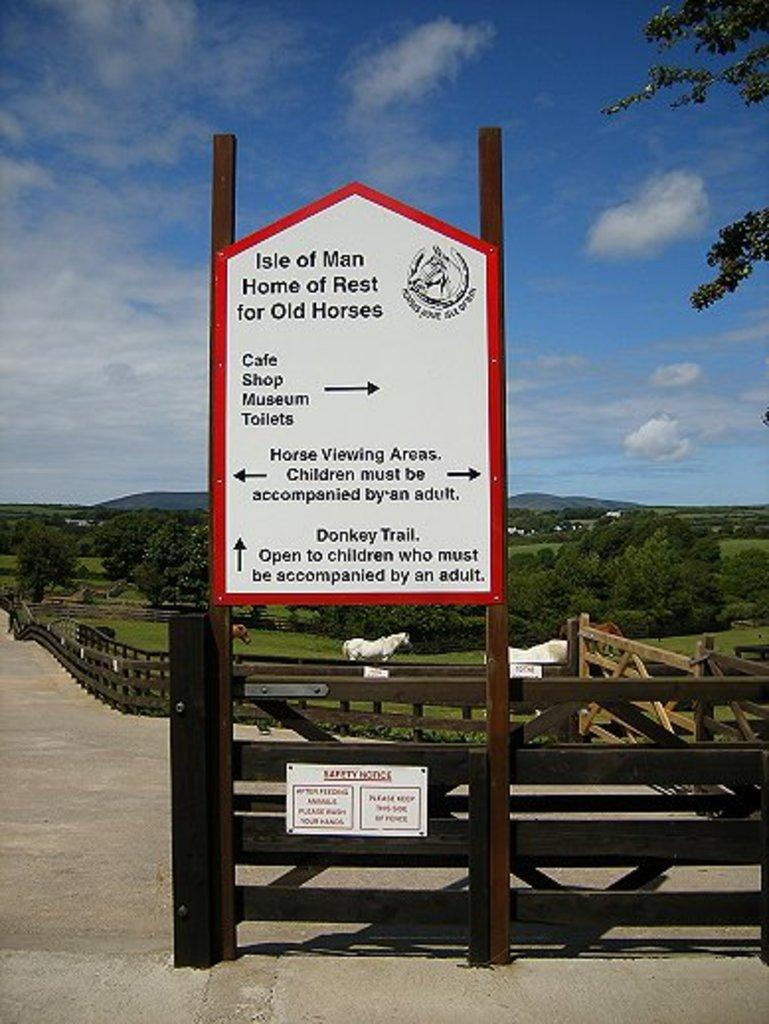What is the main object in the image? There is a board in the image. What is written or displayed on the board? There is text on the board. What type of natural environment can be seen in the image? There are trees visible in the image. What type of man-made structure is visible in the image? There is a fence visible in the image. What type of living organisms are present on the ground in the image? Animals are present on the ground in the image. What is visible at the top of the image? The sky is visible at the top of the image. How many boots are visible on the ground in the image? There are no boots present in the image; it features animals on the ground. What type of dogs are interacting with the animals on the ground in the image? There are no dogs present in the image; it features animals on the ground, but no specific type of dog is mentioned. 